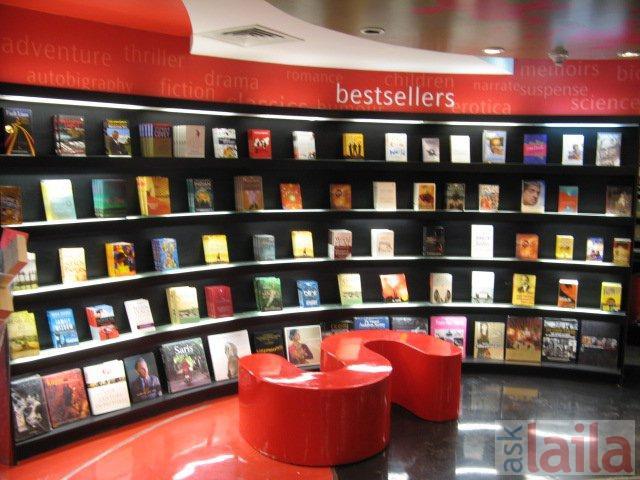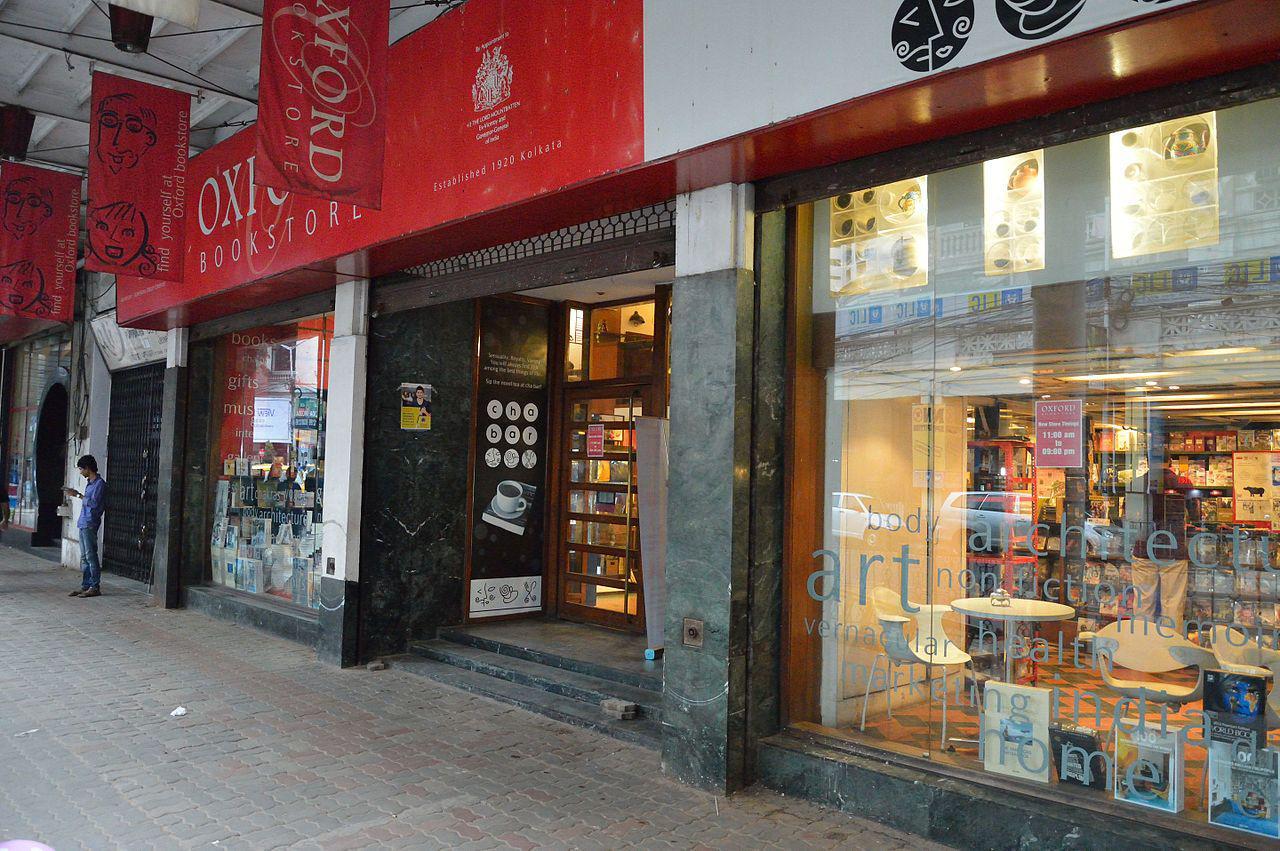The first image is the image on the left, the second image is the image on the right. Given the left and right images, does the statement "One image is a bookstore interior featuring bright red-orange on the wall above black bookshelves, and a sculptural red-orange furniture piece in front of the shelves." hold true? Answer yes or no. Yes. The first image is the image on the left, the second image is the image on the right. For the images shown, is this caption "the book store is being viewed from the second floor" true? Answer yes or no. No. 